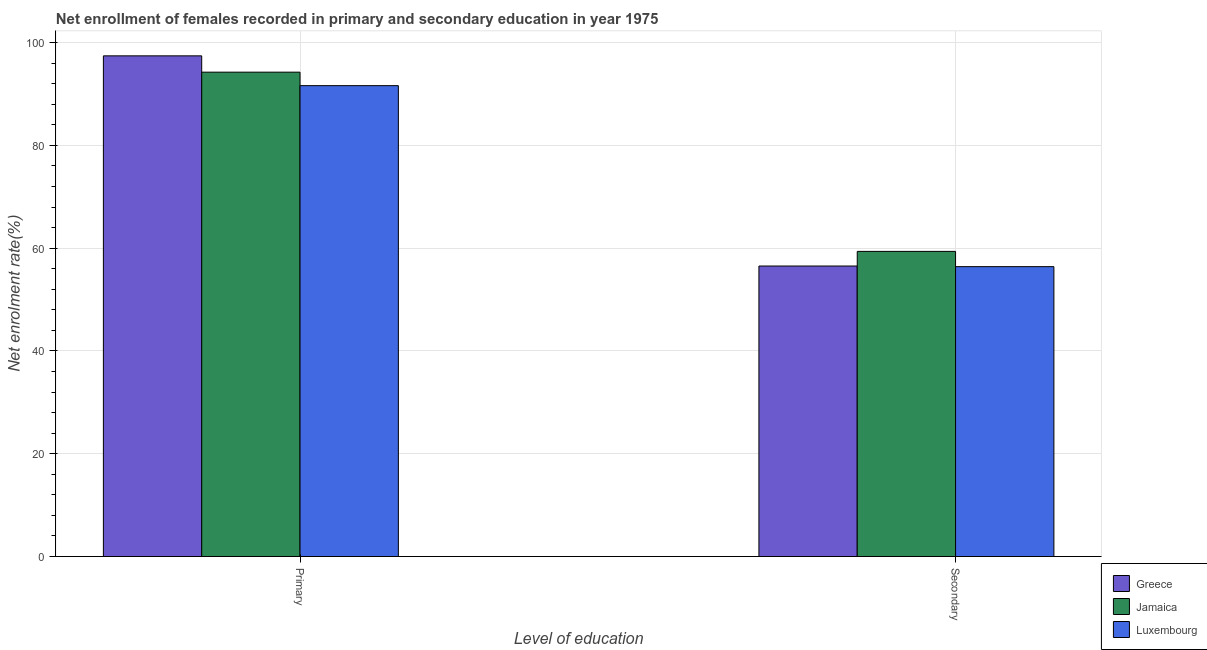How many different coloured bars are there?
Provide a succinct answer. 3. Are the number of bars per tick equal to the number of legend labels?
Offer a very short reply. Yes. How many bars are there on the 1st tick from the right?
Your answer should be very brief. 3. What is the label of the 1st group of bars from the left?
Ensure brevity in your answer.  Primary. What is the enrollment rate in primary education in Jamaica?
Your response must be concise. 94.24. Across all countries, what is the maximum enrollment rate in primary education?
Your response must be concise. 97.41. Across all countries, what is the minimum enrollment rate in primary education?
Your response must be concise. 91.62. In which country was the enrollment rate in primary education maximum?
Provide a succinct answer. Greece. In which country was the enrollment rate in secondary education minimum?
Keep it short and to the point. Luxembourg. What is the total enrollment rate in primary education in the graph?
Make the answer very short. 283.28. What is the difference between the enrollment rate in primary education in Luxembourg and that in Greece?
Make the answer very short. -5.8. What is the difference between the enrollment rate in secondary education in Luxembourg and the enrollment rate in primary education in Jamaica?
Offer a very short reply. -37.84. What is the average enrollment rate in secondary education per country?
Offer a terse response. 57.43. What is the difference between the enrollment rate in secondary education and enrollment rate in primary education in Luxembourg?
Provide a succinct answer. -35.22. What is the ratio of the enrollment rate in secondary education in Luxembourg to that in Jamaica?
Your answer should be very brief. 0.95. Is the enrollment rate in primary education in Luxembourg less than that in Greece?
Ensure brevity in your answer.  Yes. In how many countries, is the enrollment rate in secondary education greater than the average enrollment rate in secondary education taken over all countries?
Make the answer very short. 1. What does the 3rd bar from the left in Primary represents?
Your answer should be compact. Luxembourg. What does the 2nd bar from the right in Primary represents?
Your answer should be compact. Jamaica. How many bars are there?
Provide a succinct answer. 6. Are all the bars in the graph horizontal?
Your response must be concise. No. How many countries are there in the graph?
Your answer should be compact. 3. How many legend labels are there?
Offer a terse response. 3. What is the title of the graph?
Keep it short and to the point. Net enrollment of females recorded in primary and secondary education in year 1975. Does "Guyana" appear as one of the legend labels in the graph?
Offer a terse response. No. What is the label or title of the X-axis?
Offer a very short reply. Level of education. What is the label or title of the Y-axis?
Your answer should be very brief. Net enrolment rate(%). What is the Net enrolment rate(%) of Greece in Primary?
Your response must be concise. 97.41. What is the Net enrolment rate(%) of Jamaica in Primary?
Make the answer very short. 94.24. What is the Net enrolment rate(%) in Luxembourg in Primary?
Your response must be concise. 91.62. What is the Net enrolment rate(%) of Greece in Secondary?
Offer a very short reply. 56.52. What is the Net enrolment rate(%) in Jamaica in Secondary?
Make the answer very short. 59.37. What is the Net enrolment rate(%) of Luxembourg in Secondary?
Offer a very short reply. 56.4. Across all Level of education, what is the maximum Net enrolment rate(%) of Greece?
Give a very brief answer. 97.41. Across all Level of education, what is the maximum Net enrolment rate(%) in Jamaica?
Make the answer very short. 94.24. Across all Level of education, what is the maximum Net enrolment rate(%) of Luxembourg?
Your answer should be very brief. 91.62. Across all Level of education, what is the minimum Net enrolment rate(%) in Greece?
Ensure brevity in your answer.  56.52. Across all Level of education, what is the minimum Net enrolment rate(%) of Jamaica?
Your response must be concise. 59.37. Across all Level of education, what is the minimum Net enrolment rate(%) in Luxembourg?
Offer a very short reply. 56.4. What is the total Net enrolment rate(%) in Greece in the graph?
Keep it short and to the point. 153.94. What is the total Net enrolment rate(%) in Jamaica in the graph?
Give a very brief answer. 153.62. What is the total Net enrolment rate(%) of Luxembourg in the graph?
Give a very brief answer. 148.02. What is the difference between the Net enrolment rate(%) in Greece in Primary and that in Secondary?
Provide a short and direct response. 40.89. What is the difference between the Net enrolment rate(%) of Jamaica in Primary and that in Secondary?
Offer a very short reply. 34.87. What is the difference between the Net enrolment rate(%) of Luxembourg in Primary and that in Secondary?
Give a very brief answer. 35.22. What is the difference between the Net enrolment rate(%) of Greece in Primary and the Net enrolment rate(%) of Jamaica in Secondary?
Keep it short and to the point. 38.04. What is the difference between the Net enrolment rate(%) of Greece in Primary and the Net enrolment rate(%) of Luxembourg in Secondary?
Offer a terse response. 41.01. What is the difference between the Net enrolment rate(%) in Jamaica in Primary and the Net enrolment rate(%) in Luxembourg in Secondary?
Your response must be concise. 37.84. What is the average Net enrolment rate(%) in Greece per Level of education?
Your answer should be very brief. 76.97. What is the average Net enrolment rate(%) of Jamaica per Level of education?
Your response must be concise. 76.81. What is the average Net enrolment rate(%) of Luxembourg per Level of education?
Provide a succinct answer. 74.01. What is the difference between the Net enrolment rate(%) in Greece and Net enrolment rate(%) in Jamaica in Primary?
Ensure brevity in your answer.  3.17. What is the difference between the Net enrolment rate(%) of Greece and Net enrolment rate(%) of Luxembourg in Primary?
Provide a short and direct response. 5.8. What is the difference between the Net enrolment rate(%) of Jamaica and Net enrolment rate(%) of Luxembourg in Primary?
Your answer should be compact. 2.63. What is the difference between the Net enrolment rate(%) in Greece and Net enrolment rate(%) in Jamaica in Secondary?
Ensure brevity in your answer.  -2.85. What is the difference between the Net enrolment rate(%) of Greece and Net enrolment rate(%) of Luxembourg in Secondary?
Ensure brevity in your answer.  0.12. What is the difference between the Net enrolment rate(%) in Jamaica and Net enrolment rate(%) in Luxembourg in Secondary?
Provide a succinct answer. 2.97. What is the ratio of the Net enrolment rate(%) in Greece in Primary to that in Secondary?
Your answer should be compact. 1.72. What is the ratio of the Net enrolment rate(%) of Jamaica in Primary to that in Secondary?
Offer a very short reply. 1.59. What is the ratio of the Net enrolment rate(%) of Luxembourg in Primary to that in Secondary?
Make the answer very short. 1.62. What is the difference between the highest and the second highest Net enrolment rate(%) in Greece?
Offer a terse response. 40.89. What is the difference between the highest and the second highest Net enrolment rate(%) of Jamaica?
Keep it short and to the point. 34.87. What is the difference between the highest and the second highest Net enrolment rate(%) of Luxembourg?
Your answer should be compact. 35.22. What is the difference between the highest and the lowest Net enrolment rate(%) in Greece?
Make the answer very short. 40.89. What is the difference between the highest and the lowest Net enrolment rate(%) of Jamaica?
Your response must be concise. 34.87. What is the difference between the highest and the lowest Net enrolment rate(%) in Luxembourg?
Give a very brief answer. 35.22. 